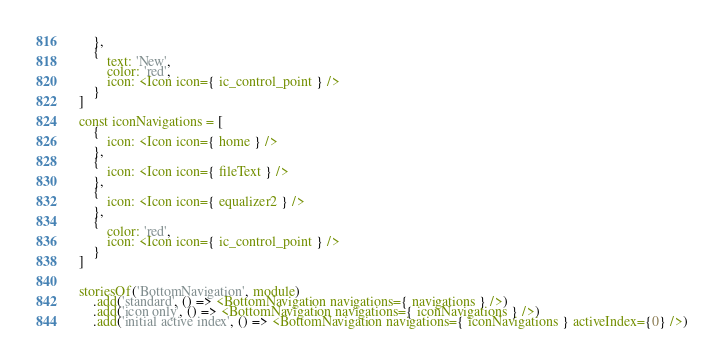Convert code to text. <code><loc_0><loc_0><loc_500><loc_500><_JavaScript_>	},
	{
		text: 'New',
		color: 'red',
		icon: <Icon icon={ ic_control_point } />
	}
]

const iconNavigations = [
	{
		icon: <Icon icon={ home } />
	},
	{
		icon: <Icon icon={ fileText } />
	},
	{
		icon: <Icon icon={ equalizer2 } />
	},
	{
		color: 'red',
		icon: <Icon icon={ ic_control_point } />
	}
]


storiesOf('BottomNavigation', module)
	.add('standard', () => <BottomNavigation navigations={ navigations } />)
	.add('icon only', () => <BottomNavigation navigations={ iconNavigations } />)
	.add('initial active index', () => <BottomNavigation navigations={ iconNavigations } activeIndex={0} />)


</code> 